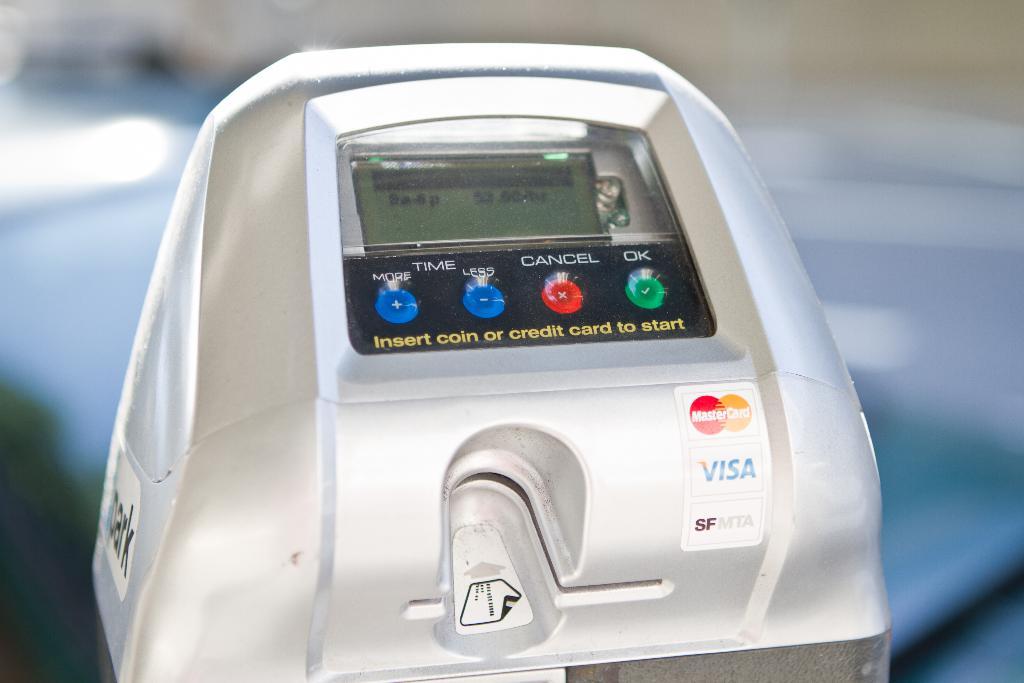What does the red button do?
Give a very brief answer. Cancel. What does the green light indicate?
Your answer should be compact. Ok. 